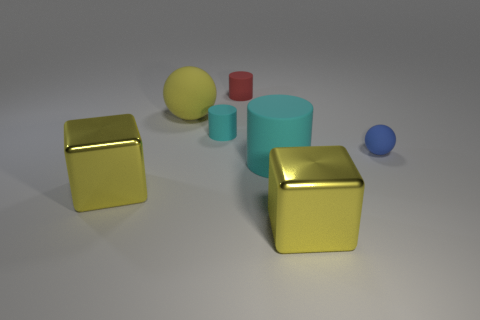Does the big metallic thing that is right of the small red rubber object have the same shape as the big yellow object behind the tiny cyan rubber thing?
Offer a very short reply. No. Is the number of red things in front of the large yellow sphere the same as the number of large yellow spheres?
Your answer should be very brief. No. Is there any other thing that is the same size as the blue sphere?
Provide a short and direct response. Yes. There is another big thing that is the same shape as the red matte thing; what is it made of?
Keep it short and to the point. Rubber. The large metallic object right of the cylinder in front of the small blue thing is what shape?
Offer a terse response. Cube. Do the cylinder that is behind the large sphere and the blue sphere have the same material?
Your answer should be compact. Yes. Are there the same number of matte things that are behind the red rubber thing and yellow metallic things to the right of the small blue sphere?
Give a very brief answer. Yes. What material is the object that is the same color as the big matte cylinder?
Your answer should be compact. Rubber. How many big blocks are behind the large metal cube on the left side of the big cyan object?
Your response must be concise. 0. Does the big matte object that is in front of the blue object have the same color as the large metal cube on the right side of the red object?
Offer a terse response. No. 